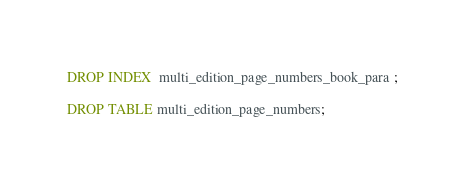Convert code to text. <code><loc_0><loc_0><loc_500><loc_500><_SQL_>DROP INDEX  multi_edition_page_numbers_book_para ;

DROP TABLE multi_edition_page_numbers;

</code> 